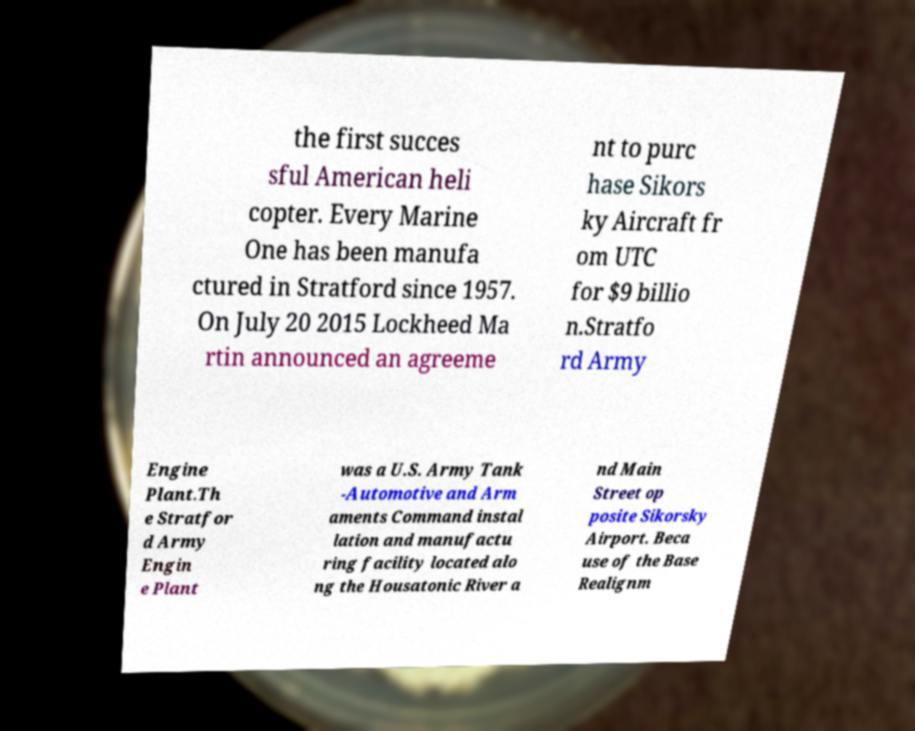What messages or text are displayed in this image? I need them in a readable, typed format. the first succes sful American heli copter. Every Marine One has been manufa ctured in Stratford since 1957. On July 20 2015 Lockheed Ma rtin announced an agreeme nt to purc hase Sikors ky Aircraft fr om UTC for $9 billio n.Stratfo rd Army Engine Plant.Th e Stratfor d Army Engin e Plant was a U.S. Army Tank -Automotive and Arm aments Command instal lation and manufactu ring facility located alo ng the Housatonic River a nd Main Street op posite Sikorsky Airport. Beca use of the Base Realignm 